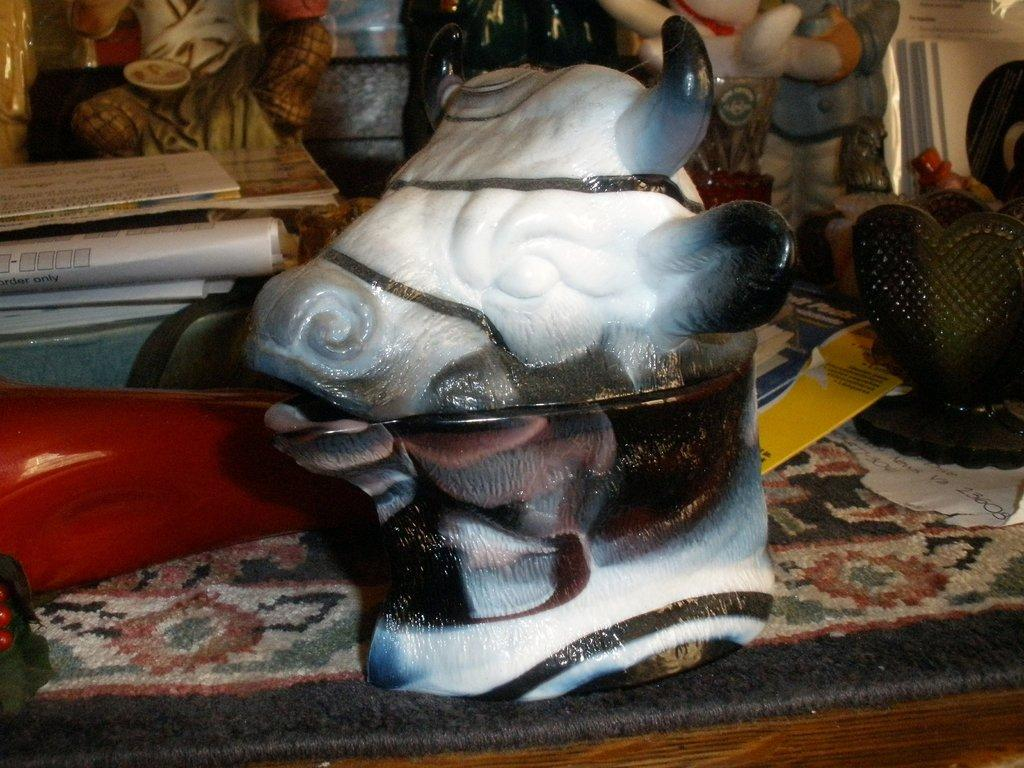What is the main subject of the image? There is a sculpture in the image. Where is the sculpture located? The sculpture is on a carpet. What can be found behind the carpet? There are papers and other things behind the carpet. What material is the carpet made of? The carpet is made of wood. What is the purpose of the farmer in the image? There is no farmer present in the image; it features a sculpture on a wooden carpet. 